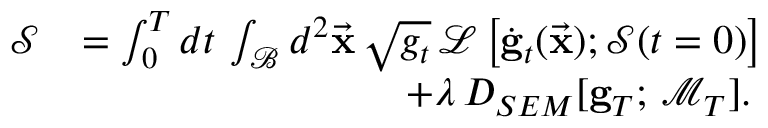Convert formula to latex. <formula><loc_0><loc_0><loc_500><loc_500>\begin{array} { r l } { \mathcal { S } } & { = \int _ { 0 } ^ { T } d t \, \int _ { \mathcal { B } } d ^ { 2 } \vec { x } \, \sqrt { g _ { t } } \, \mathcal { L } \left [ \dot { g } _ { t } ( \vec { x } ) ; \mathcal { S } ( t = 0 ) \right ] } \\ & { \quad + \lambda \, D _ { S E M } [ { g } _ { T } ; \, \mathcal { M } _ { T } ] . } \end{array}</formula> 